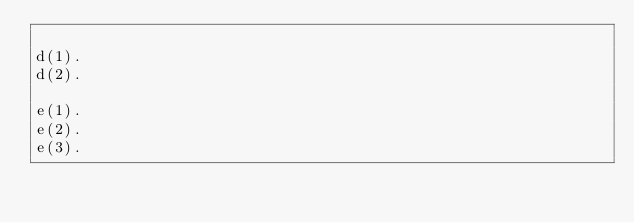<code> <loc_0><loc_0><loc_500><loc_500><_Perl_>
d(1).
d(2).

e(1).
e(2).
e(3).


</code> 